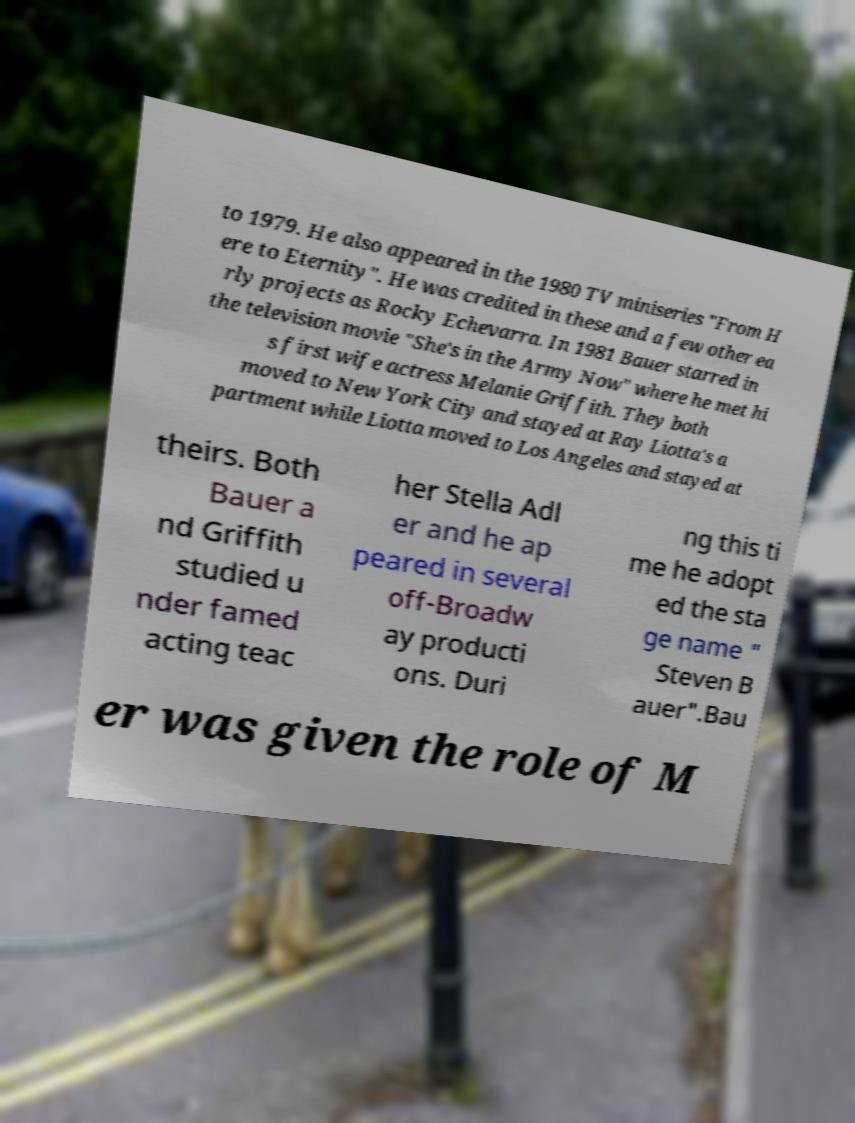Could you extract and type out the text from this image? to 1979. He also appeared in the 1980 TV miniseries "From H ere to Eternity". He was credited in these and a few other ea rly projects as Rocky Echevarra. In 1981 Bauer starred in the television movie "She's in the Army Now" where he met hi s first wife actress Melanie Griffith. They both moved to New York City and stayed at Ray Liotta's a partment while Liotta moved to Los Angeles and stayed at theirs. Both Bauer a nd Griffith studied u nder famed acting teac her Stella Adl er and he ap peared in several off-Broadw ay producti ons. Duri ng this ti me he adopt ed the sta ge name " Steven B auer".Bau er was given the role of M 